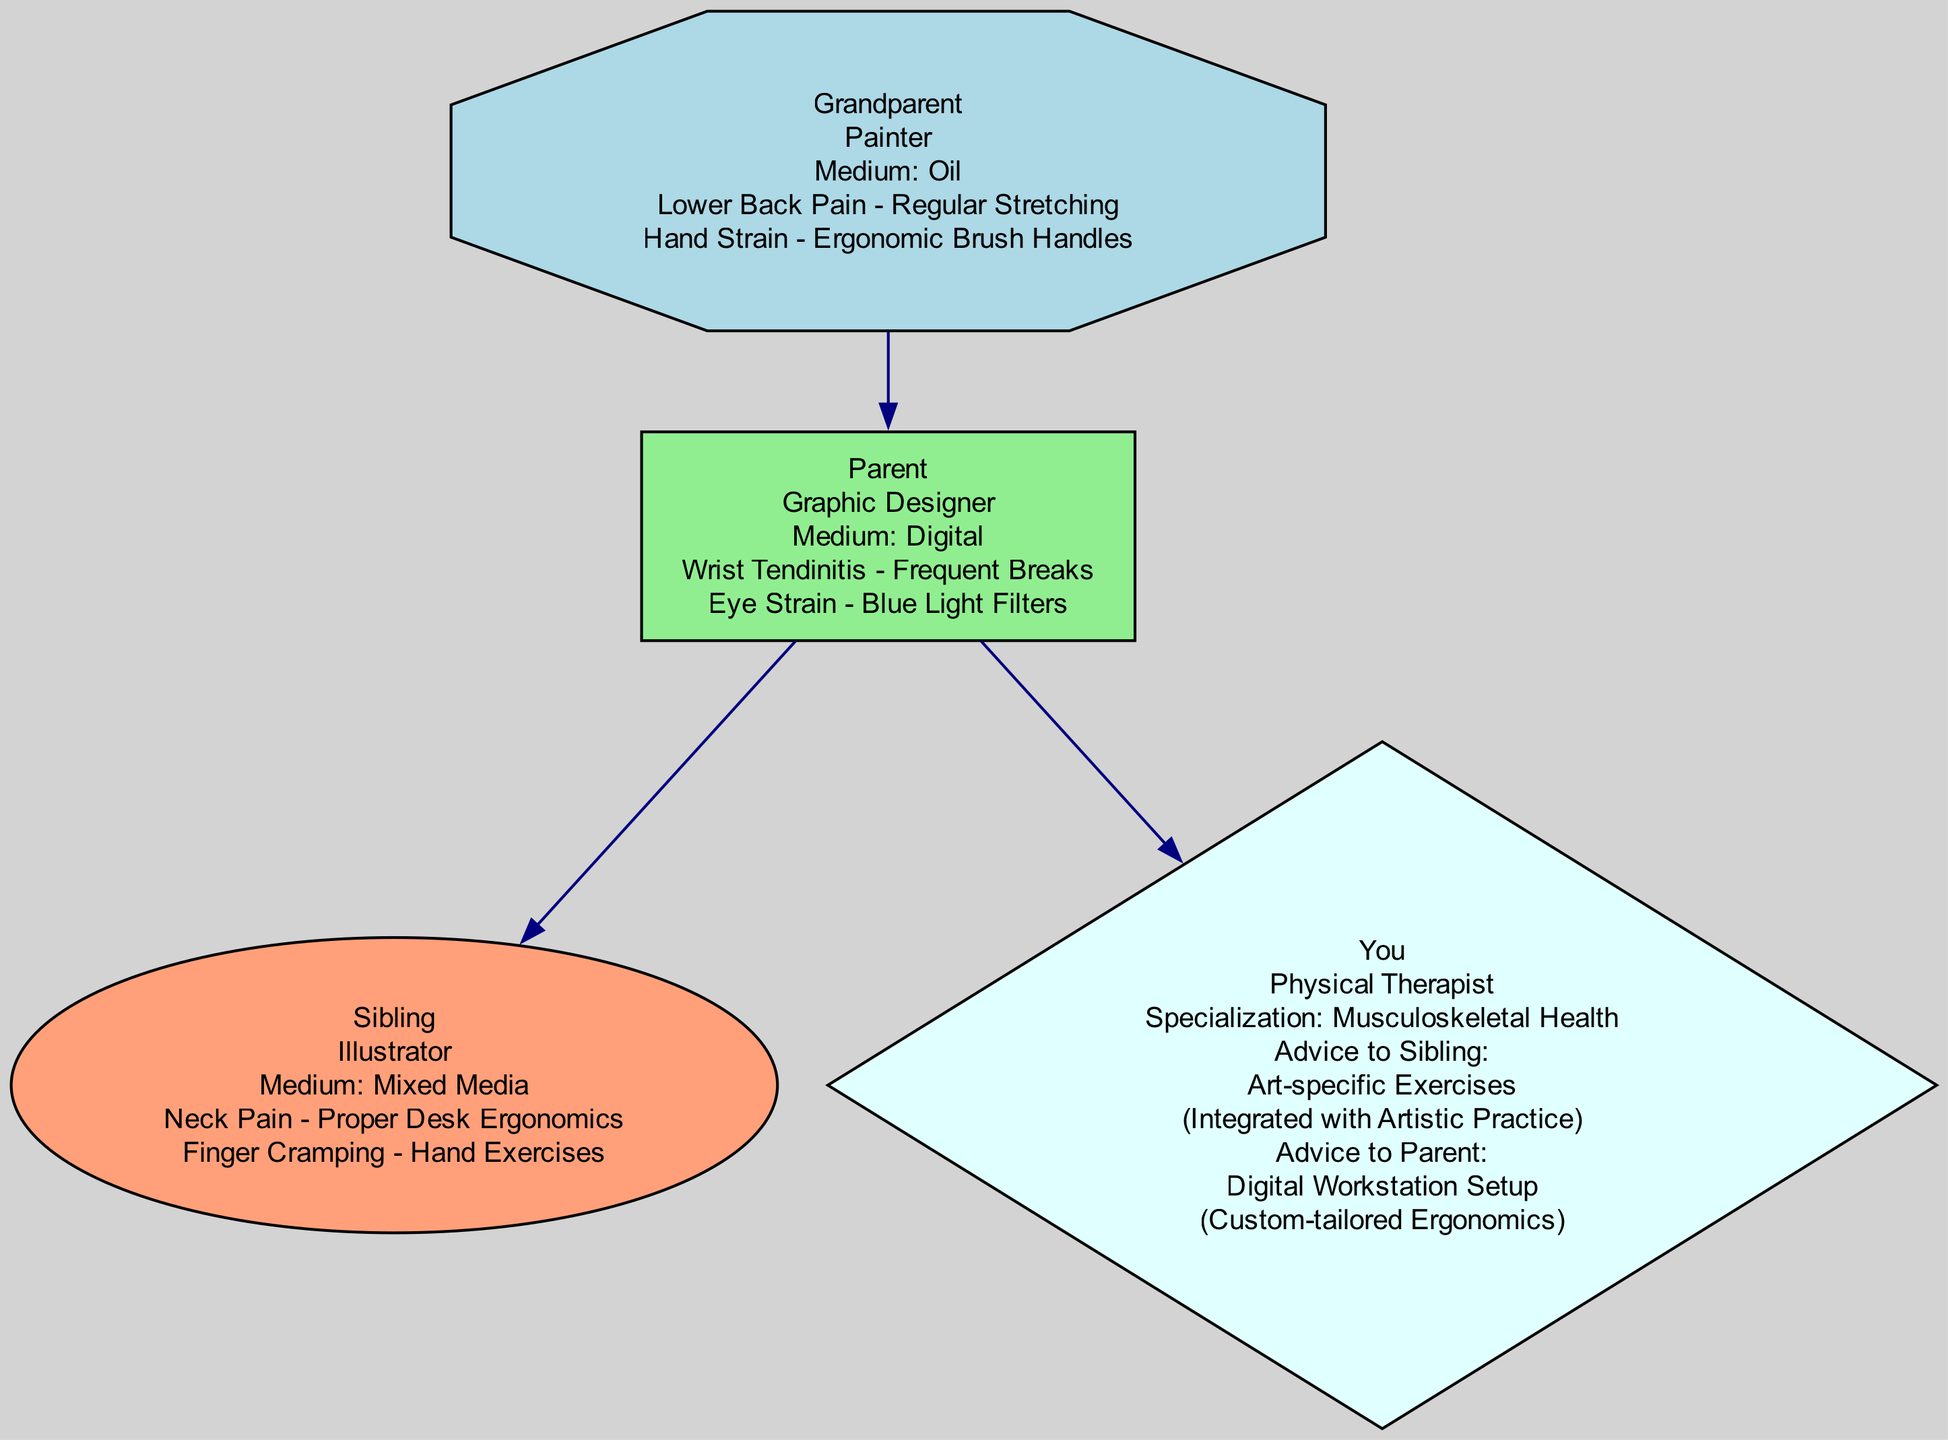What is the profession of the Grandparent? The Grandparent node specifically lists that their profession is "Painter" as stated on the rendered diagram.
Answer: Painter How many generational injuries does the Parent have? The Parent node contains a list of two injuries. By counting the entries under "generation_injuries", we find that there are two.
Answer: 2 What is the medium used by the Sibling? The Sibling node mentions "Mixed Media" as the medium in their description on the diagram, which provides this information.
Answer: Mixed Media Which injury does the Parent suffer from? The injuries listed under the Parent node show "Wrist Tendinitis" and "Eye Strain" as two conditions. Both of these injuries are explicitly detailed, but for clarity, we can mention either.
Answer: Wrist Tendinitis What injury prevention technique does the Grandparent use for Hand Strain? According to the Grandparent's injuries listed, they use "Ergonomic Brush Handles" as the prevention technique for Hand Strain, which is directly included in the diagram.
Answer: Ergonomic Brush Handles Which other profession is mentioned in the family tree? By reviewing the diagram, we see that other professions listed include "Graphic Designer", "Illustrator", and "Physical Therapist". The question specifically asks for any other profession besides the Grandparent’s.
Answer: Graphic Designer What advice is given to the Sibling? Upon examining the Sibling node and the advice given nodes, we find the specific advice directed to them is "Art-specific Exercises" which is detailed within the context of the advice.
Answer: Art-specific Exercises How is the relationship between the Parent and the Grandparent depicted in the diagram? The diagram establishes a parent-child relationship with an edge connecting the Parent node to the Grandparent node, which signifies the parent-child connection.
Answer: Parent-child What specialization does 'You' have? In the node labeled 'You', it specifies "Musculoskeletal Health" as the specialization. This is clearly noted in the diagram.
Answer: Musculoskeletal Health 